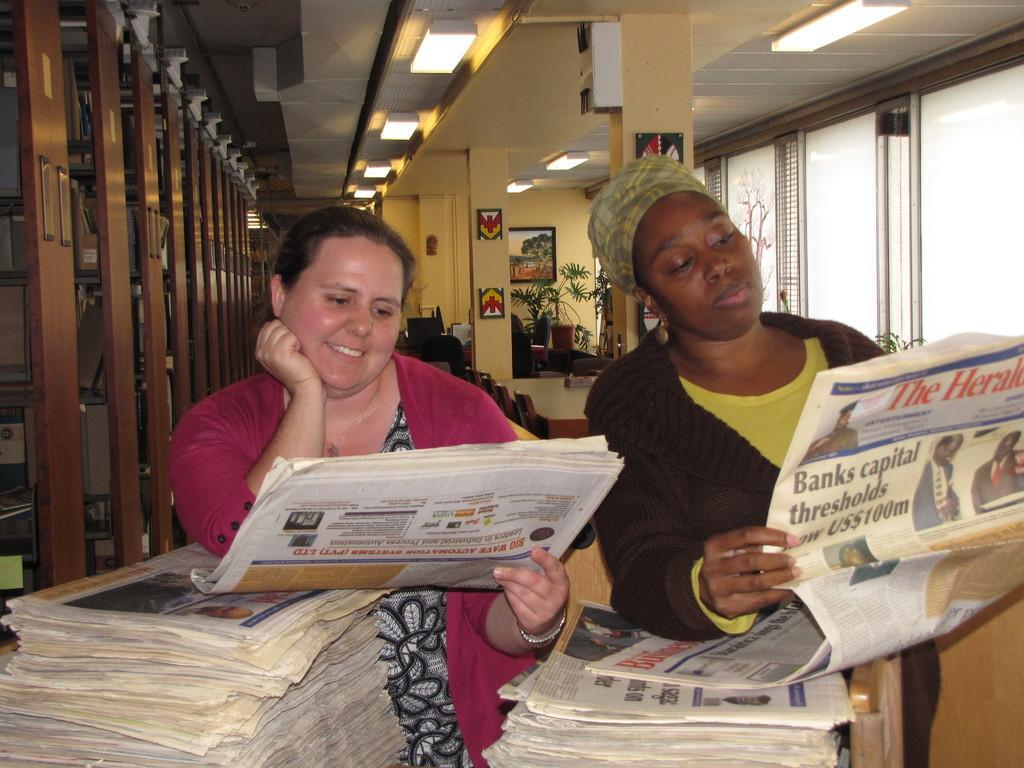Please provide a concise description of this image. This picture is clicked inside. In the foreground we can see there are many number of papers and we can see the two persons standing, holding newspapers and seems to be reading. In the background we can see the windows, roof, ceiling lights, picture frame hanging on the wall and we can see the house plants and some other objects. 